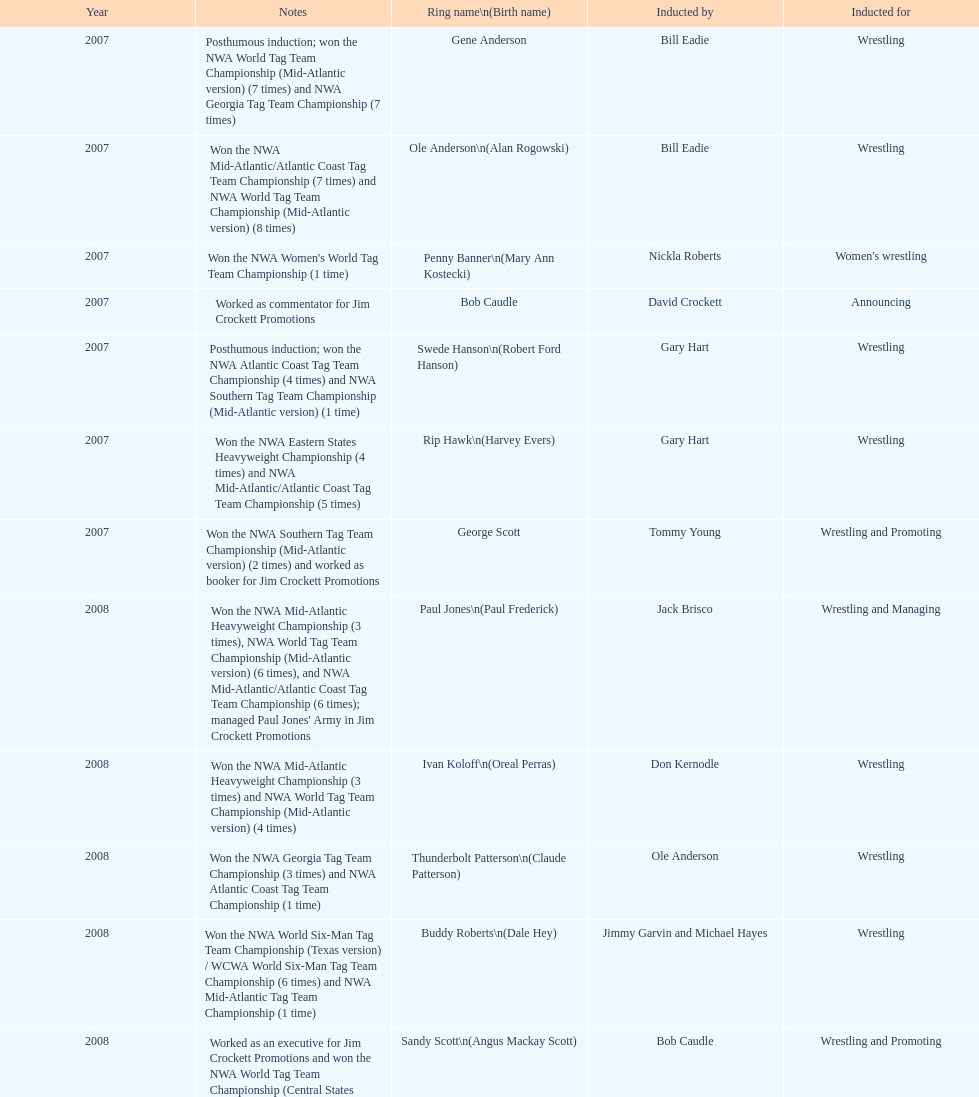How many members were inducted for announcing? 2. 